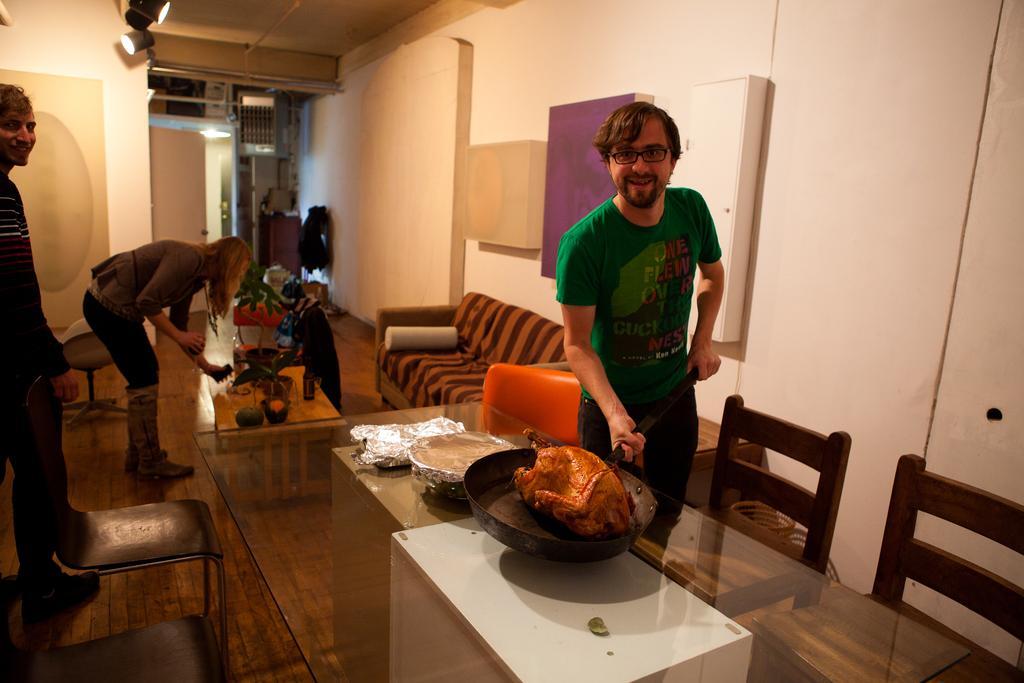Could you give a brief overview of what you see in this image? In this picture there is a man, holding a pan with his both hands, kept on the table. There is a woman behind him and also a person standing on the left. 